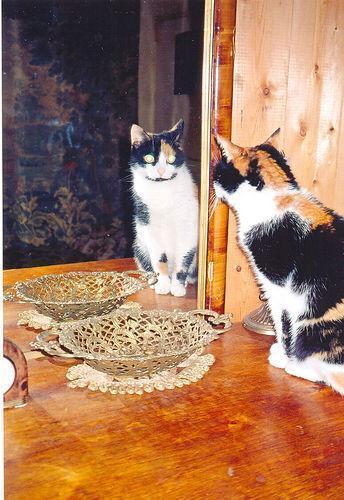How many animals appear in this photo?
Give a very brief answer. 1. How many people are pictured?
Give a very brief answer. 0. How many cats are in the scene?
Give a very brief answer. 1. How many colors is the cat?
Give a very brief answer. 3. How many cats are in the photo?
Give a very brief answer. 2. 